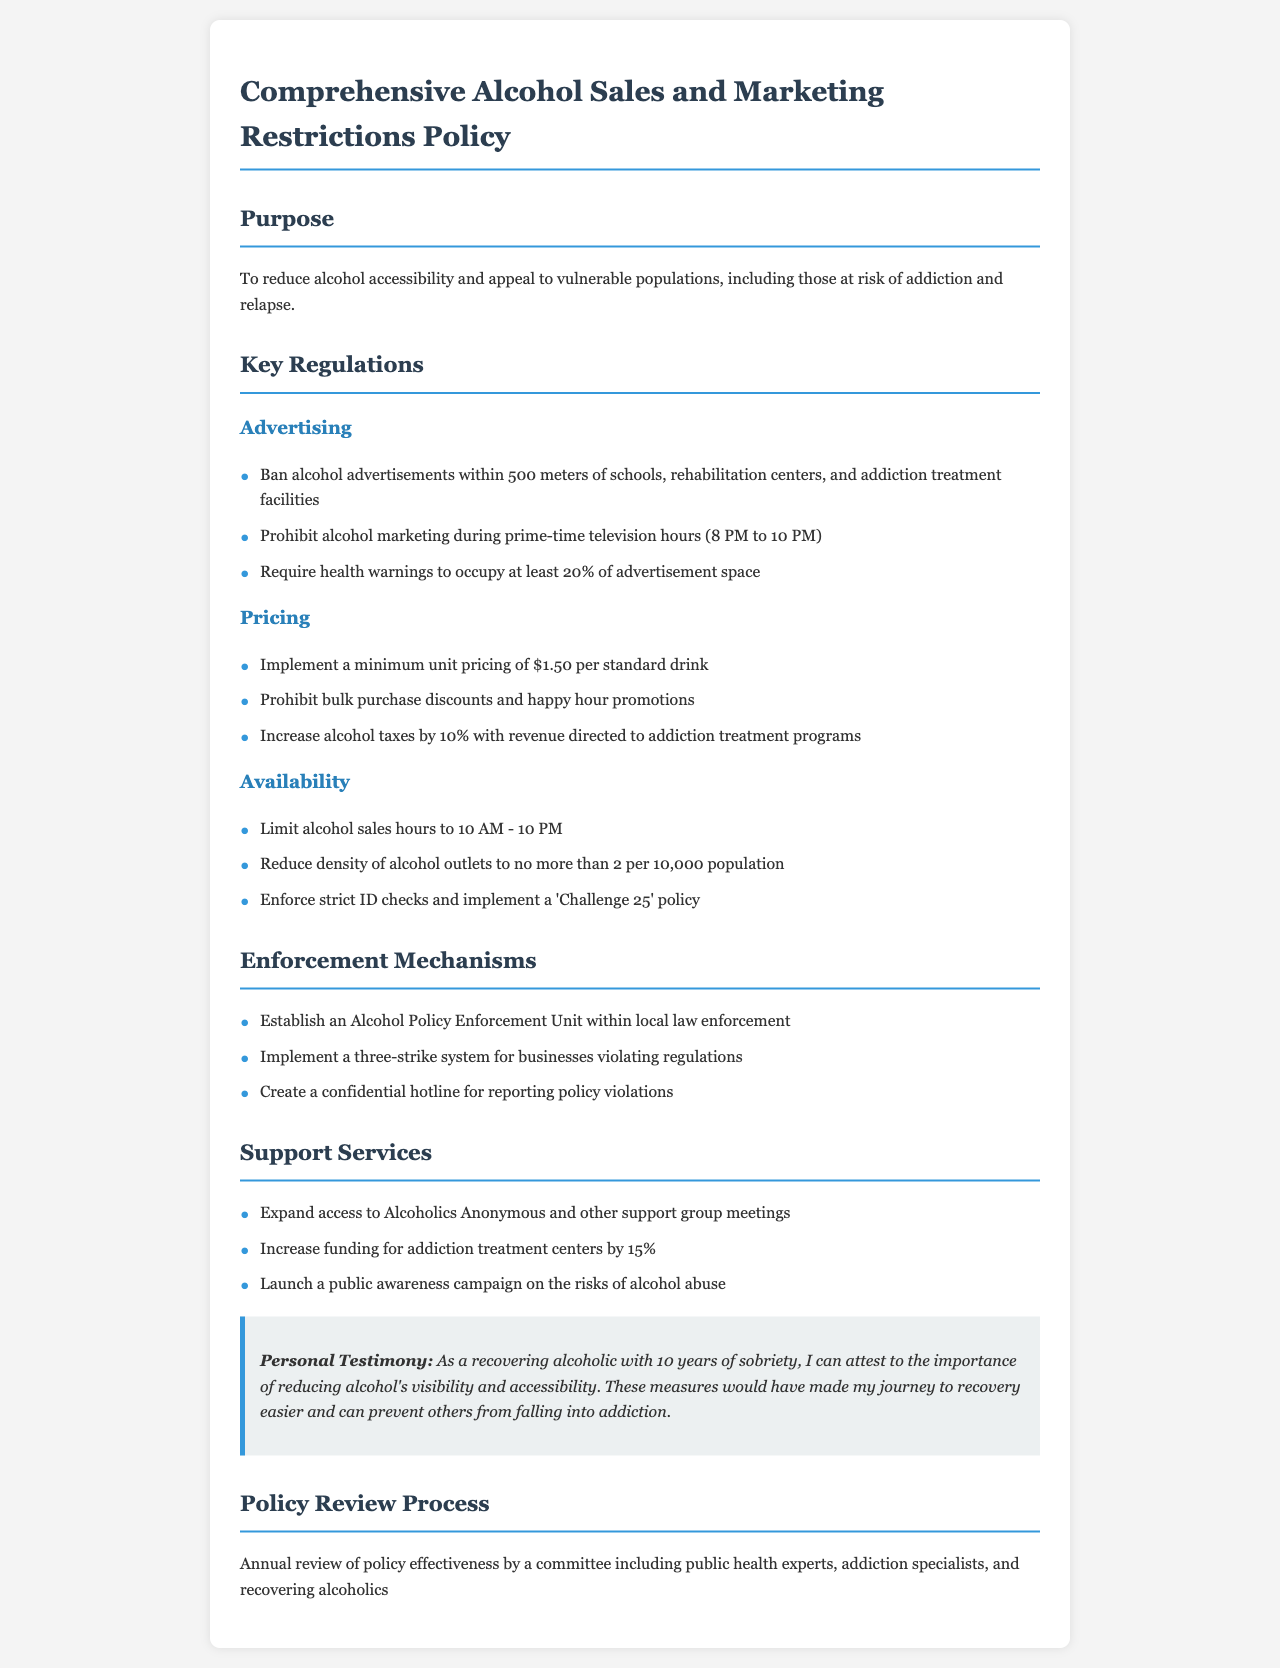What is the purpose of the policy? The purpose is stated explicitly in the document to reduce alcohol accessibility and appeal to vulnerable populations, including those at risk of addiction and relapse.
Answer: To reduce alcohol accessibility and appeal to vulnerable populations What is the minimum unit pricing per standard drink? The minimum unit pricing is specifically mentioned in the pricing regulations section of the document.
Answer: $1.50 What are the alcohol sales hours limited to? The limitation on sales hours is clearly stated in the availability section of the document.
Answer: 10 AM - 10 PM How far must alcohol advertisements be from schools and treatment facilities? This distance is given in the advertising regulations section of the document.
Answer: 500 meters What is the percentage of advertisement space required for health warnings? The document specifies the health warning requirement in the advertising section.
Answer: 20% What is the enforcement mechanism for businesses violating regulations? The document describes a specific enforcement mechanism under the enforcement section for businesses that do not comply.
Answer: Three-strike system What organization is mentioned for expanding access to support services? The support services section references a specific organization dedicated to helping individuals in recovery.
Answer: Alcoholics Anonymous What committee is responsible for the annual review of policy effectiveness? The document states that a committee with specific expertise will perform the review process mentioned in the document.
Answer: Public health experts, addiction specialists, and recovering alcoholics 